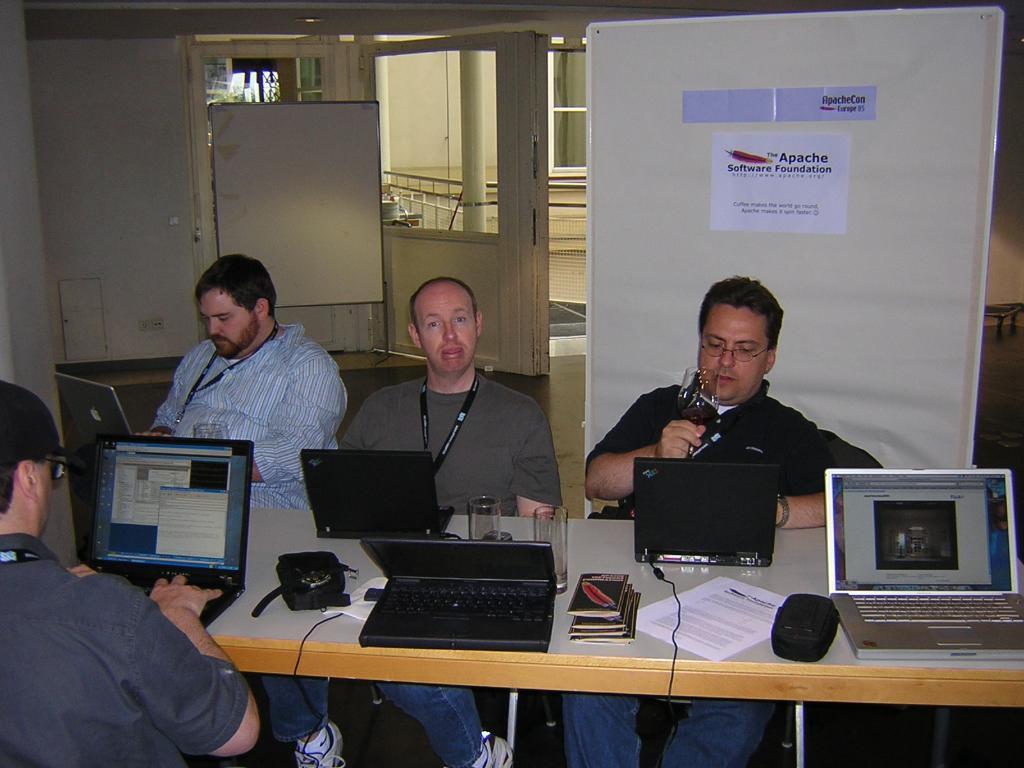Please provide a concise description of this image. In this image I can see few people are sitting on chairs. I can also see number of laptops on this table. In the background I can see a white board. 